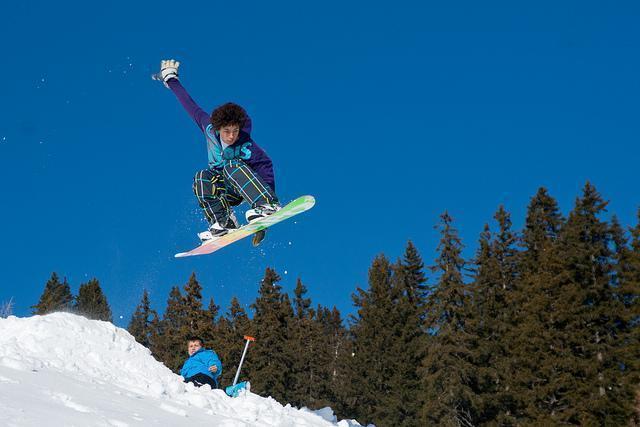How many reflections of a cat are visible?
Give a very brief answer. 0. 